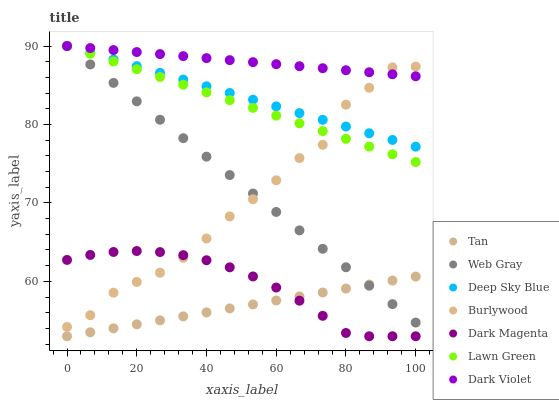Does Tan have the minimum area under the curve?
Answer yes or no. Yes. Does Dark Violet have the maximum area under the curve?
Answer yes or no. Yes. Does Web Gray have the minimum area under the curve?
Answer yes or no. No. Does Web Gray have the maximum area under the curve?
Answer yes or no. No. Is Web Gray the smoothest?
Answer yes or no. Yes. Is Burlywood the roughest?
Answer yes or no. Yes. Is Dark Magenta the smoothest?
Answer yes or no. No. Is Dark Magenta the roughest?
Answer yes or no. No. Does Dark Magenta have the lowest value?
Answer yes or no. Yes. Does Web Gray have the lowest value?
Answer yes or no. No. Does Deep Sky Blue have the highest value?
Answer yes or no. Yes. Does Dark Magenta have the highest value?
Answer yes or no. No. Is Tan less than Dark Violet?
Answer yes or no. Yes. Is Deep Sky Blue greater than Tan?
Answer yes or no. Yes. Does Burlywood intersect Dark Violet?
Answer yes or no. Yes. Is Burlywood less than Dark Violet?
Answer yes or no. No. Is Burlywood greater than Dark Violet?
Answer yes or no. No. Does Tan intersect Dark Violet?
Answer yes or no. No. 